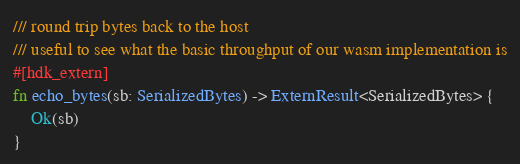<code> <loc_0><loc_0><loc_500><loc_500><_Rust_>/// round trip bytes back to the host
/// useful to see what the basic throughput of our wasm implementation is
#[hdk_extern]
fn echo_bytes(sb: SerializedBytes) -> ExternResult<SerializedBytes> {
    Ok(sb)
}
</code> 